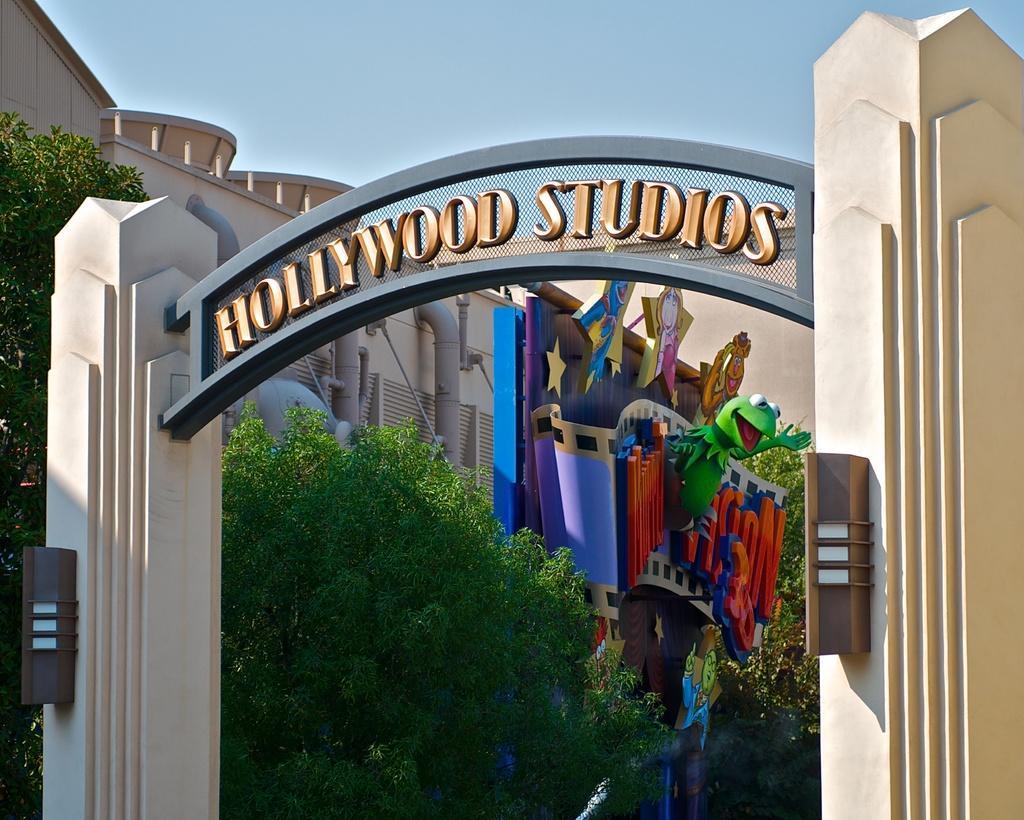Describe this image in one or two sentences. In the foreground of the picture there is an arch with some text on it. In the center of the picture there are trees. In the background there is a building and there are pipes and other objects. 